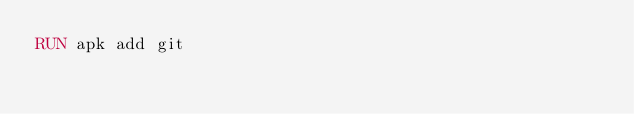Convert code to text. <code><loc_0><loc_0><loc_500><loc_500><_Dockerfile_>RUN apk add git
</code> 